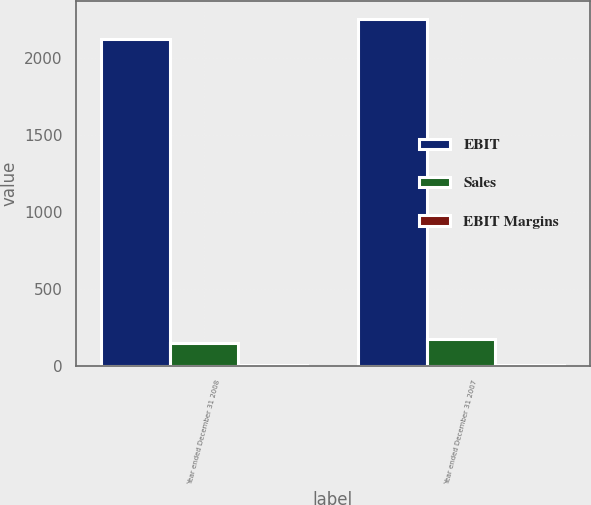Convert chart to OTSL. <chart><loc_0><loc_0><loc_500><loc_500><stacked_bar_chart><ecel><fcel>Year ended December 31 2008<fcel>Year ended December 31 2007<nl><fcel>EBIT<fcel>2120<fcel>2254<nl><fcel>Sales<fcel>151<fcel>174<nl><fcel>EBIT Margins<fcel>7.1<fcel>7.7<nl></chart> 